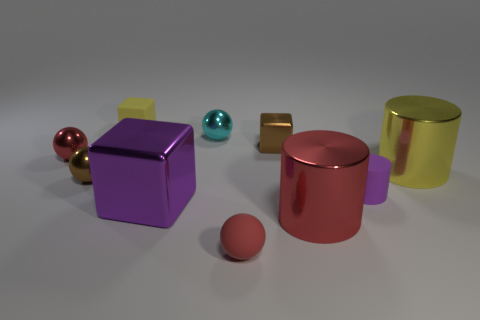What kind of lighting setup can you infer from the image? The image seems to be lit by a soft overhead source, as indicated by the soft shadows under the objects. The reflection on the glossy surfaces suggests possibly one or more additional softer light sources to highlight their curvature and reflective properties. Given the shadows and reflections, can you guess the time of day or the type of environment where this image was taken? The controlled lighting and consistent background suggest this is a studio setup rather than a natural environment. Therefore, it doesn't depict a real-world time of day but is rather a scene created to showcase the objects and their materials under specific lighting conditions. 